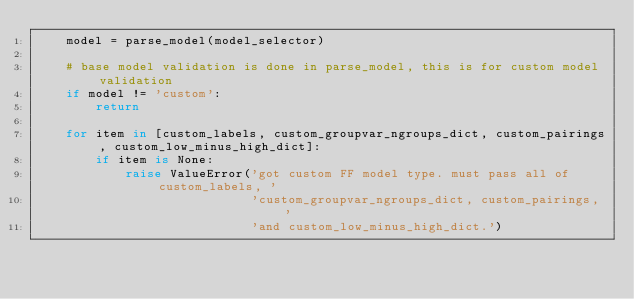<code> <loc_0><loc_0><loc_500><loc_500><_Python_>    model = parse_model(model_selector)

    # base model validation is done in parse_model, this is for custom model validation
    if model != 'custom':
        return

    for item in [custom_labels, custom_groupvar_ngroups_dict, custom_pairings, custom_low_minus_high_dict]:
        if item is None:
            raise ValueError('got custom FF model type. must pass all of custom_labels, '
                             'custom_groupvar_ngroups_dict, custom_pairings, '
                             'and custom_low_minus_high_dict.')

</code> 